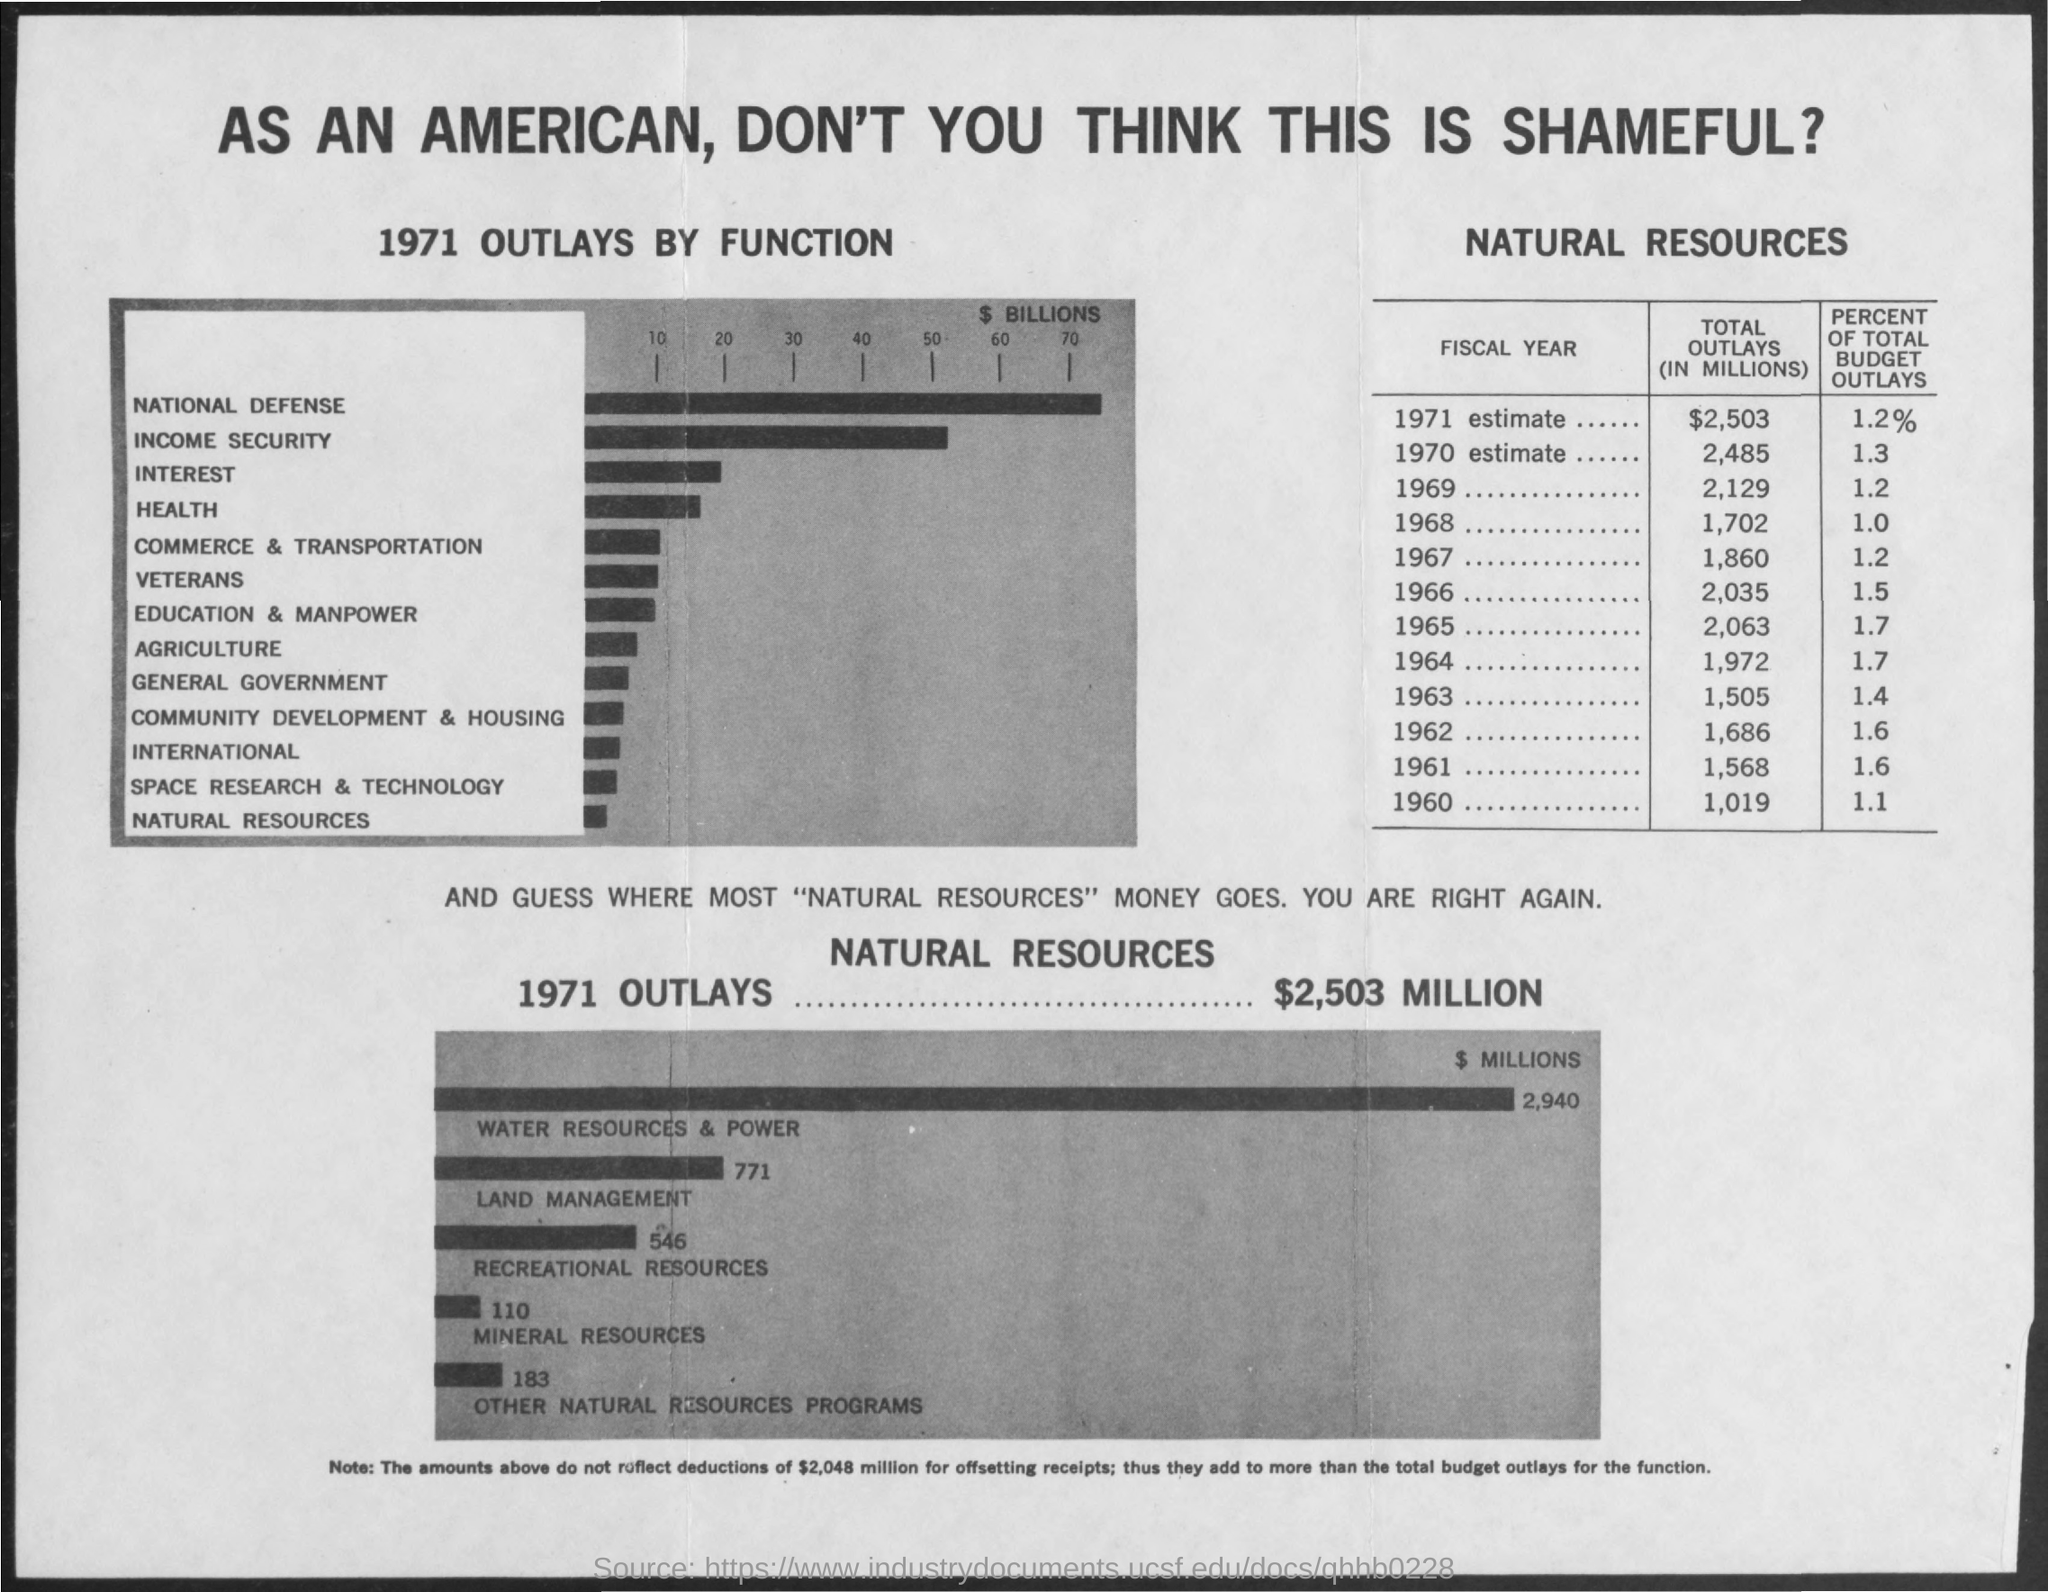Highlight a few significant elements in this photo. The total outlay is expected to be highest in the year 1971. In 1971, the minimum outlay for natural resources was observed. According to the outlays in 1971, a total of 1.2% of the budget was spent. The total outlay in 1969 was 2,129. The total outlay is minimum in the year 1960. 